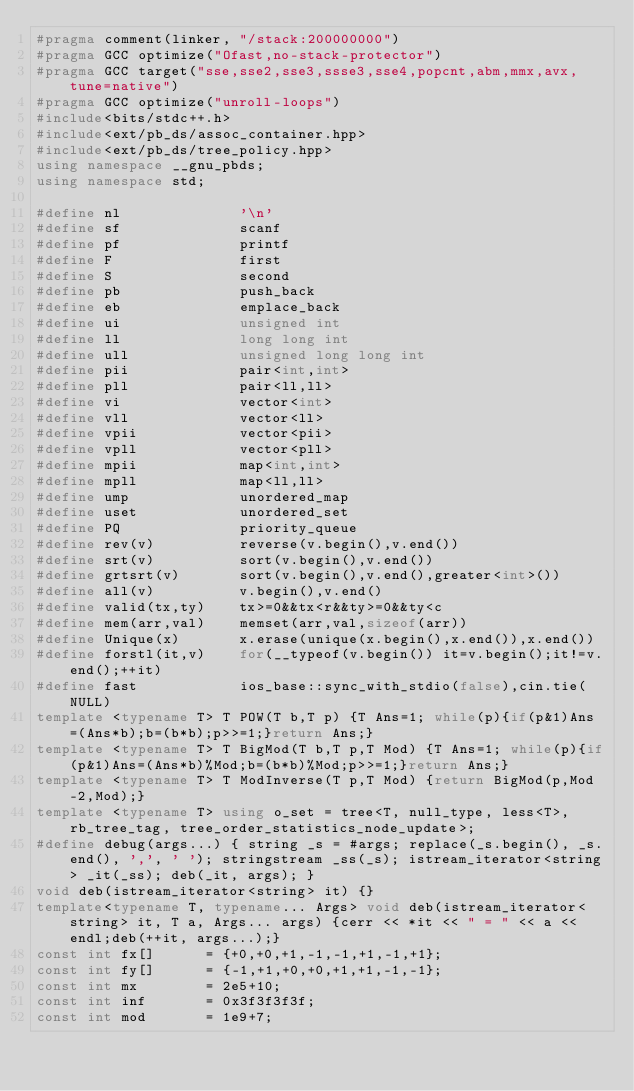<code> <loc_0><loc_0><loc_500><loc_500><_C++_>#pragma comment(linker, "/stack:200000000")
#pragma GCC optimize("Ofast,no-stack-protector")
#pragma GCC target("sse,sse2,sse3,ssse3,sse4,popcnt,abm,mmx,avx,tune=native")
#pragma GCC optimize("unroll-loops")
#include<bits/stdc++.h>
#include<ext/pb_ds/assoc_container.hpp>
#include<ext/pb_ds/tree_policy.hpp>
using namespace __gnu_pbds;
using namespace std;

#define nl              '\n'
#define sf              scanf
#define pf              printf
#define F               first
#define S               second
#define pb              push_back
#define eb              emplace_back
#define ui              unsigned int
#define ll              long long int
#define ull             unsigned long long int
#define pii             pair<int,int>
#define pll             pair<ll,ll>
#define vi              vector<int>
#define vll             vector<ll>
#define vpii            vector<pii>
#define vpll            vector<pll>
#define mpii            map<int,int>
#define mpll            map<ll,ll>
#define ump             unordered_map
#define uset            unordered_set
#define PQ              priority_queue
#define rev(v)          reverse(v.begin(),v.end())
#define srt(v)          sort(v.begin(),v.end())
#define grtsrt(v)       sort(v.begin(),v.end(),greater<int>())
#define all(v)          v.begin(),v.end()
#define valid(tx,ty)    tx>=0&&tx<r&&ty>=0&&ty<c
#define mem(arr,val)    memset(arr,val,sizeof(arr))
#define Unique(x)       x.erase(unique(x.begin(),x.end()),x.end())
#define forstl(it,v)    for(__typeof(v.begin()) it=v.begin();it!=v.end();++it)
#define fast            ios_base::sync_with_stdio(false),cin.tie(NULL)
template <typename T> T POW(T b,T p) {T Ans=1; while(p){if(p&1)Ans=(Ans*b);b=(b*b);p>>=1;}return Ans;}
template <typename T> T BigMod(T b,T p,T Mod) {T Ans=1; while(p){if(p&1)Ans=(Ans*b)%Mod;b=(b*b)%Mod;p>>=1;}return Ans;}
template <typename T> T ModInverse(T p,T Mod) {return BigMod(p,Mod-2,Mod);}
template <typename T> using o_set = tree<T, null_type, less<T>, rb_tree_tag, tree_order_statistics_node_update>;
#define debug(args...) { string _s = #args; replace(_s.begin(), _s.end(), ',', ' '); stringstream _ss(_s); istream_iterator<string> _it(_ss); deb(_it, args); }
void deb(istream_iterator<string> it) {}
template<typename T, typename... Args> void deb(istream_iterator<string> it, T a, Args... args) {cerr << *it << " = " << a << endl;deb(++it, args...);}
const int fx[]      = {+0,+0,+1,-1,-1,+1,-1,+1};
const int fy[]      = {-1,+1,+0,+0,+1,+1,-1,-1};
const int mx        = 2e5+10;
const int inf       = 0x3f3f3f3f;
const int mod       = 1e9+7;</code> 